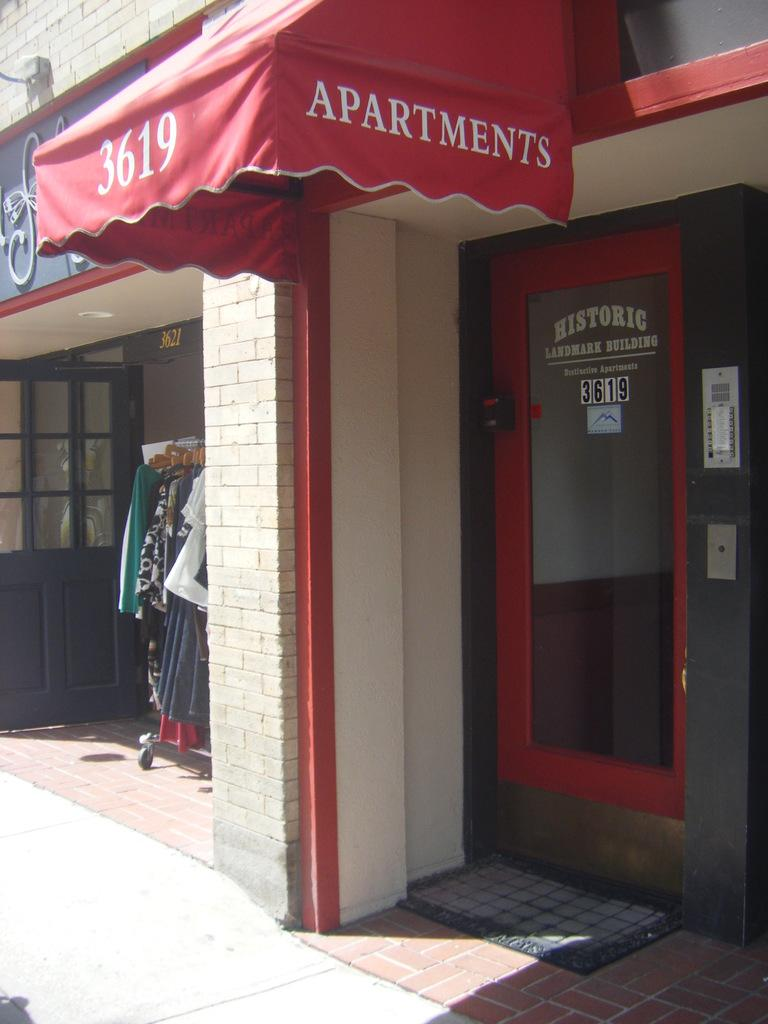What type of establishment is shown in the image? There is a store in the image. What can be seen on the store? There is text on the store. How can customers enter the store? There is a door in the image. What type of items are visible in the store? There are clothes visible in the image. What is placed in front of the door? There is a mat in the image. How many cherries are hanging from the ceiling in the image? There are no cherries present in the image. Are there any jellyfish swimming in the store in the image? There are no jellyfish present in the image. 